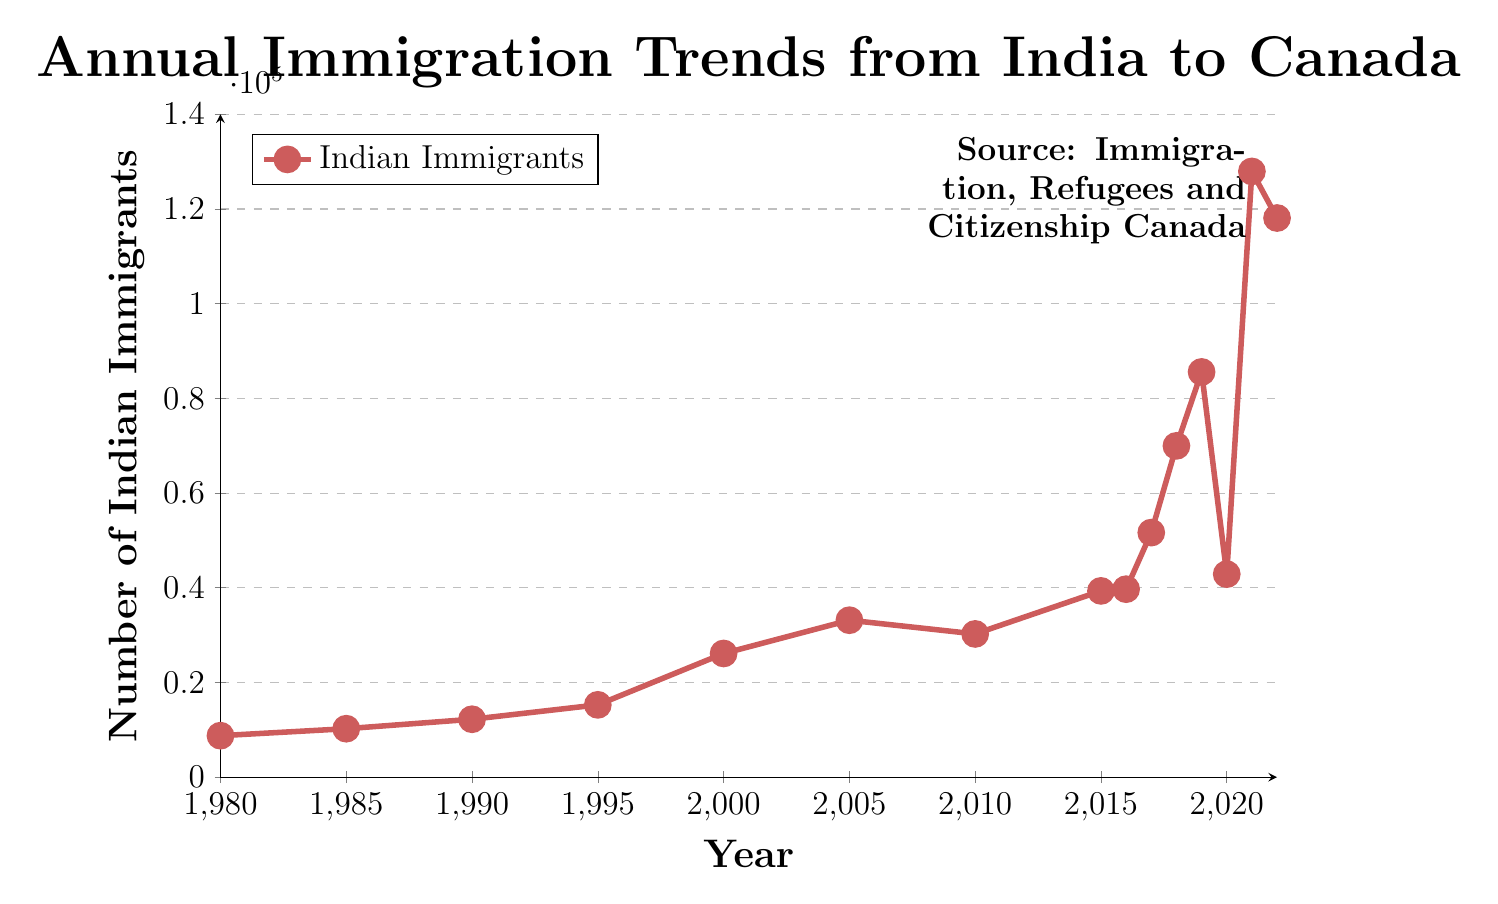What is the highest number of Indian immigrants to Canada in the given period? The maximum number of immigrants can be identified by spotting the highest point on the line. According to the data, the peak occurs in 2021, with 127933 immigrants.
Answer: 127933 Which year experienced the sharpest increase in the number of Indian immigrants to Canada? To identify the year with the sharpest increase, look for the steepest slope between consecutive points on the chart. The steepest increase is seen from 2019 to 2021 (85585 to 127933), an increase of 42348.
Answer: 2019 to 2021 Compare the number of Indian immigrants in 1985 and 2022. By how much has the number increased? The number of immigrants in 1985 was 10234, and in 2022 it was 118095. The increase can be calculated as 118095 - 10234 = 107861.
Answer: 107861 What was the trend in Indian immigration to Canada between 2010 and 2015? To discern the trend, observe the line from 2010 to 2015. The numbers rose from 30252 in 2010 to 39340 in 2015, which indicates an increasing trend.
Answer: Increasing What is the average number of Indian immigrants per year from 1980 to 2022? Sum all the data points from 1980 to 2022: (8761 + 10234 + 12231 + 15273 + 26123 + 33148 + 30252 + 39340 + 39705 + 51651 + 69973 + 85585 + 42876 + 127933 + 118095) = 740180. There are 15 years, so the average is 740180 / 15 = 49345.33.
Answer: 49345.33 What was the number of immigrants in the year before the highest point was reached? The highest point is in 2021 with 127933 immigrants. The year before that, 2020, saw 42876 immigrants.
Answer: 42876 What was the smallest recorded number of immigrants, and in which year did it occur? The smallest number is the lowest point on the chart. The data shows 8761 immigrants in 1980.
Answer: 8761 in 1980 How does the number of immigrants in 2005 compare to that in 2015? The number of immigrants in 2005 was 33148, and in 2015 it was 39340. Thus, the number increased by 39340 - 33148 = 6192.
Answer: Increased by 6192 How many times did the number of Indian immigrants exceed 50000 per year? From the data, years 2017, 2018, 2019, 2021, and 2022 had more than 50000 immigrants. That counts to 5 times.
Answer: 5 times Between which consecutive years was the largest drop in the number of Indian immigrants observed? The largest drop is the steepest downward slope. Between 2019 and 2020, the number dropped from 85585 to 42876, a decrease of 42709.
Answer: 2019 to 2020 